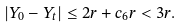Convert formula to latex. <formula><loc_0><loc_0><loc_500><loc_500>| Y _ { 0 } - Y _ { t } | \leq 2 r + c _ { 6 } r < 3 r .</formula> 